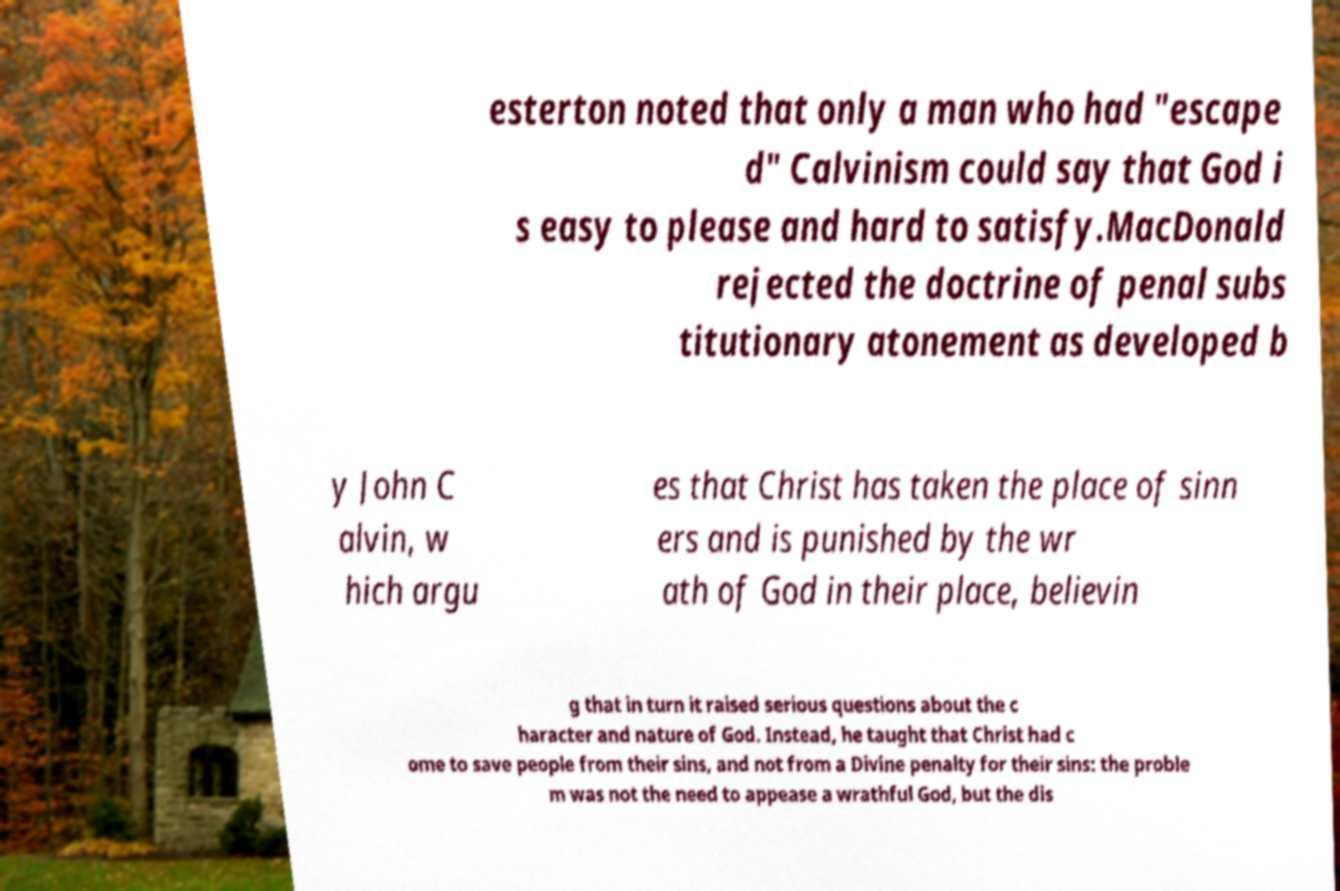Can you read and provide the text displayed in the image?This photo seems to have some interesting text. Can you extract and type it out for me? esterton noted that only a man who had "escape d" Calvinism could say that God i s easy to please and hard to satisfy.MacDonald rejected the doctrine of penal subs titutionary atonement as developed b y John C alvin, w hich argu es that Christ has taken the place of sinn ers and is punished by the wr ath of God in their place, believin g that in turn it raised serious questions about the c haracter and nature of God. Instead, he taught that Christ had c ome to save people from their sins, and not from a Divine penalty for their sins: the proble m was not the need to appease a wrathful God, but the dis 